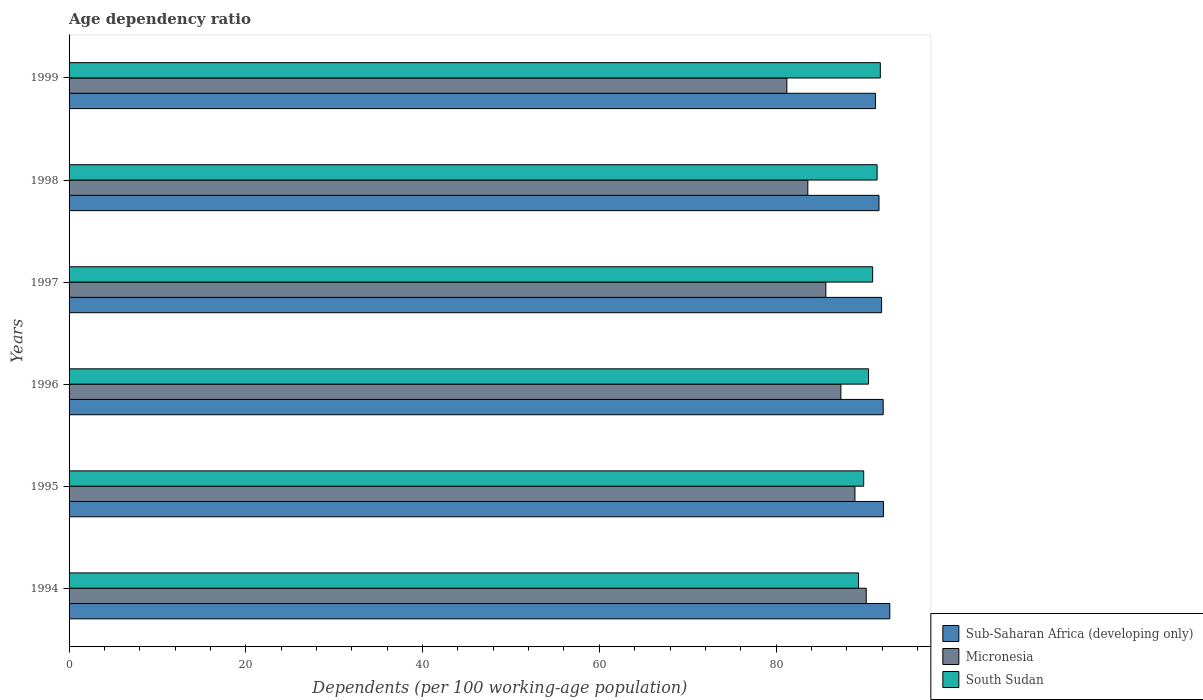How many bars are there on the 5th tick from the bottom?
Give a very brief answer. 3. What is the label of the 1st group of bars from the top?
Your answer should be very brief. 1999. What is the age dependency ratio in in Sub-Saharan Africa (developing only) in 1997?
Make the answer very short. 91.94. Across all years, what is the maximum age dependency ratio in in Micronesia?
Make the answer very short. 90.2. Across all years, what is the minimum age dependency ratio in in Sub-Saharan Africa (developing only)?
Provide a short and direct response. 91.25. In which year was the age dependency ratio in in Micronesia maximum?
Offer a terse response. 1994. What is the total age dependency ratio in in Micronesia in the graph?
Make the answer very short. 516.88. What is the difference between the age dependency ratio in in South Sudan in 1995 and that in 1996?
Ensure brevity in your answer.  -0.55. What is the difference between the age dependency ratio in in South Sudan in 1994 and the age dependency ratio in in Micronesia in 1996?
Make the answer very short. 2. What is the average age dependency ratio in in Micronesia per year?
Offer a terse response. 86.15. In the year 1995, what is the difference between the age dependency ratio in in South Sudan and age dependency ratio in in Micronesia?
Provide a short and direct response. 0.99. In how many years, is the age dependency ratio in in Sub-Saharan Africa (developing only) greater than 8 %?
Your answer should be very brief. 6. What is the ratio of the age dependency ratio in in Micronesia in 1996 to that in 1999?
Provide a succinct answer. 1.08. What is the difference between the highest and the second highest age dependency ratio in in South Sudan?
Your answer should be compact. 0.36. What is the difference between the highest and the lowest age dependency ratio in in Micronesia?
Ensure brevity in your answer.  8.98. Is the sum of the age dependency ratio in in South Sudan in 1996 and 1997 greater than the maximum age dependency ratio in in Micronesia across all years?
Provide a short and direct response. Yes. What does the 3rd bar from the top in 1995 represents?
Make the answer very short. Sub-Saharan Africa (developing only). What does the 3rd bar from the bottom in 1994 represents?
Ensure brevity in your answer.  South Sudan. How many bars are there?
Make the answer very short. 18. Are all the bars in the graph horizontal?
Provide a succinct answer. Yes. Are the values on the major ticks of X-axis written in scientific E-notation?
Your response must be concise. No. Does the graph contain any zero values?
Offer a terse response. No. Does the graph contain grids?
Your answer should be compact. No. How many legend labels are there?
Give a very brief answer. 3. How are the legend labels stacked?
Ensure brevity in your answer.  Vertical. What is the title of the graph?
Offer a very short reply. Age dependency ratio. What is the label or title of the X-axis?
Keep it short and to the point. Dependents (per 100 working-age population). What is the Dependents (per 100 working-age population) in Sub-Saharan Africa (developing only) in 1994?
Your answer should be compact. 92.87. What is the Dependents (per 100 working-age population) of Micronesia in 1994?
Keep it short and to the point. 90.2. What is the Dependents (per 100 working-age population) in South Sudan in 1994?
Your answer should be compact. 89.33. What is the Dependents (per 100 working-age population) of Sub-Saharan Africa (developing only) in 1995?
Make the answer very short. 92.15. What is the Dependents (per 100 working-age population) of Micronesia in 1995?
Give a very brief answer. 88.92. What is the Dependents (per 100 working-age population) in South Sudan in 1995?
Your answer should be compact. 89.91. What is the Dependents (per 100 working-age population) in Sub-Saharan Africa (developing only) in 1996?
Keep it short and to the point. 92.11. What is the Dependents (per 100 working-age population) of Micronesia in 1996?
Your answer should be very brief. 87.33. What is the Dependents (per 100 working-age population) of South Sudan in 1996?
Make the answer very short. 90.46. What is the Dependents (per 100 working-age population) in Sub-Saharan Africa (developing only) in 1997?
Keep it short and to the point. 91.94. What is the Dependents (per 100 working-age population) of Micronesia in 1997?
Provide a succinct answer. 85.63. What is the Dependents (per 100 working-age population) in South Sudan in 1997?
Ensure brevity in your answer.  90.92. What is the Dependents (per 100 working-age population) of Sub-Saharan Africa (developing only) in 1998?
Make the answer very short. 91.64. What is the Dependents (per 100 working-age population) of Micronesia in 1998?
Keep it short and to the point. 83.59. What is the Dependents (per 100 working-age population) of South Sudan in 1998?
Offer a terse response. 91.43. What is the Dependents (per 100 working-age population) in Sub-Saharan Africa (developing only) in 1999?
Your answer should be compact. 91.25. What is the Dependents (per 100 working-age population) in Micronesia in 1999?
Your response must be concise. 81.22. What is the Dependents (per 100 working-age population) of South Sudan in 1999?
Make the answer very short. 91.79. Across all years, what is the maximum Dependents (per 100 working-age population) in Sub-Saharan Africa (developing only)?
Your response must be concise. 92.87. Across all years, what is the maximum Dependents (per 100 working-age population) of Micronesia?
Offer a terse response. 90.2. Across all years, what is the maximum Dependents (per 100 working-age population) in South Sudan?
Ensure brevity in your answer.  91.79. Across all years, what is the minimum Dependents (per 100 working-age population) of Sub-Saharan Africa (developing only)?
Offer a terse response. 91.25. Across all years, what is the minimum Dependents (per 100 working-age population) of Micronesia?
Offer a very short reply. 81.22. Across all years, what is the minimum Dependents (per 100 working-age population) of South Sudan?
Offer a terse response. 89.33. What is the total Dependents (per 100 working-age population) in Sub-Saharan Africa (developing only) in the graph?
Provide a succinct answer. 551.96. What is the total Dependents (per 100 working-age population) in Micronesia in the graph?
Give a very brief answer. 516.88. What is the total Dependents (per 100 working-age population) in South Sudan in the graph?
Your answer should be very brief. 543.85. What is the difference between the Dependents (per 100 working-age population) of Sub-Saharan Africa (developing only) in 1994 and that in 1995?
Keep it short and to the point. 0.71. What is the difference between the Dependents (per 100 working-age population) of Micronesia in 1994 and that in 1995?
Offer a very short reply. 1.28. What is the difference between the Dependents (per 100 working-age population) in South Sudan in 1994 and that in 1995?
Keep it short and to the point. -0.58. What is the difference between the Dependents (per 100 working-age population) of Sub-Saharan Africa (developing only) in 1994 and that in 1996?
Ensure brevity in your answer.  0.75. What is the difference between the Dependents (per 100 working-age population) of Micronesia in 1994 and that in 1996?
Your answer should be very brief. 2.87. What is the difference between the Dependents (per 100 working-age population) of South Sudan in 1994 and that in 1996?
Your answer should be very brief. -1.13. What is the difference between the Dependents (per 100 working-age population) of Sub-Saharan Africa (developing only) in 1994 and that in 1997?
Give a very brief answer. 0.93. What is the difference between the Dependents (per 100 working-age population) of Micronesia in 1994 and that in 1997?
Give a very brief answer. 4.57. What is the difference between the Dependents (per 100 working-age population) in South Sudan in 1994 and that in 1997?
Your answer should be very brief. -1.59. What is the difference between the Dependents (per 100 working-age population) of Sub-Saharan Africa (developing only) in 1994 and that in 1998?
Keep it short and to the point. 1.22. What is the difference between the Dependents (per 100 working-age population) in Micronesia in 1994 and that in 1998?
Offer a terse response. 6.61. What is the difference between the Dependents (per 100 working-age population) of South Sudan in 1994 and that in 1998?
Offer a terse response. -2.1. What is the difference between the Dependents (per 100 working-age population) of Sub-Saharan Africa (developing only) in 1994 and that in 1999?
Keep it short and to the point. 1.62. What is the difference between the Dependents (per 100 working-age population) in Micronesia in 1994 and that in 1999?
Keep it short and to the point. 8.98. What is the difference between the Dependents (per 100 working-age population) in South Sudan in 1994 and that in 1999?
Keep it short and to the point. -2.46. What is the difference between the Dependents (per 100 working-age population) in Sub-Saharan Africa (developing only) in 1995 and that in 1996?
Offer a terse response. 0.04. What is the difference between the Dependents (per 100 working-age population) of Micronesia in 1995 and that in 1996?
Give a very brief answer. 1.59. What is the difference between the Dependents (per 100 working-age population) in South Sudan in 1995 and that in 1996?
Give a very brief answer. -0.55. What is the difference between the Dependents (per 100 working-age population) of Sub-Saharan Africa (developing only) in 1995 and that in 1997?
Offer a very short reply. 0.21. What is the difference between the Dependents (per 100 working-age population) of Micronesia in 1995 and that in 1997?
Your response must be concise. 3.29. What is the difference between the Dependents (per 100 working-age population) of South Sudan in 1995 and that in 1997?
Your response must be concise. -1.01. What is the difference between the Dependents (per 100 working-age population) in Sub-Saharan Africa (developing only) in 1995 and that in 1998?
Keep it short and to the point. 0.51. What is the difference between the Dependents (per 100 working-age population) of Micronesia in 1995 and that in 1998?
Offer a very short reply. 5.33. What is the difference between the Dependents (per 100 working-age population) in South Sudan in 1995 and that in 1998?
Ensure brevity in your answer.  -1.52. What is the difference between the Dependents (per 100 working-age population) in Sub-Saharan Africa (developing only) in 1995 and that in 1999?
Offer a terse response. 0.9. What is the difference between the Dependents (per 100 working-age population) of Micronesia in 1995 and that in 1999?
Your answer should be very brief. 7.7. What is the difference between the Dependents (per 100 working-age population) in South Sudan in 1995 and that in 1999?
Give a very brief answer. -1.88. What is the difference between the Dependents (per 100 working-age population) of Sub-Saharan Africa (developing only) in 1996 and that in 1997?
Offer a terse response. 0.18. What is the difference between the Dependents (per 100 working-age population) in Micronesia in 1996 and that in 1997?
Offer a very short reply. 1.7. What is the difference between the Dependents (per 100 working-age population) of South Sudan in 1996 and that in 1997?
Your answer should be very brief. -0.47. What is the difference between the Dependents (per 100 working-age population) in Sub-Saharan Africa (developing only) in 1996 and that in 1998?
Provide a succinct answer. 0.47. What is the difference between the Dependents (per 100 working-age population) of Micronesia in 1996 and that in 1998?
Your response must be concise. 3.74. What is the difference between the Dependents (per 100 working-age population) in South Sudan in 1996 and that in 1998?
Provide a succinct answer. -0.97. What is the difference between the Dependents (per 100 working-age population) of Sub-Saharan Africa (developing only) in 1996 and that in 1999?
Provide a succinct answer. 0.87. What is the difference between the Dependents (per 100 working-age population) in Micronesia in 1996 and that in 1999?
Provide a succinct answer. 6.11. What is the difference between the Dependents (per 100 working-age population) in South Sudan in 1996 and that in 1999?
Ensure brevity in your answer.  -1.33. What is the difference between the Dependents (per 100 working-age population) in Sub-Saharan Africa (developing only) in 1997 and that in 1998?
Provide a succinct answer. 0.29. What is the difference between the Dependents (per 100 working-age population) of Micronesia in 1997 and that in 1998?
Give a very brief answer. 2.04. What is the difference between the Dependents (per 100 working-age population) of South Sudan in 1997 and that in 1998?
Provide a succinct answer. -0.5. What is the difference between the Dependents (per 100 working-age population) in Sub-Saharan Africa (developing only) in 1997 and that in 1999?
Your response must be concise. 0.69. What is the difference between the Dependents (per 100 working-age population) of Micronesia in 1997 and that in 1999?
Make the answer very short. 4.41. What is the difference between the Dependents (per 100 working-age population) in South Sudan in 1997 and that in 1999?
Offer a terse response. -0.87. What is the difference between the Dependents (per 100 working-age population) of Sub-Saharan Africa (developing only) in 1998 and that in 1999?
Give a very brief answer. 0.4. What is the difference between the Dependents (per 100 working-age population) of Micronesia in 1998 and that in 1999?
Your answer should be very brief. 2.37. What is the difference between the Dependents (per 100 working-age population) of South Sudan in 1998 and that in 1999?
Offer a very short reply. -0.36. What is the difference between the Dependents (per 100 working-age population) of Sub-Saharan Africa (developing only) in 1994 and the Dependents (per 100 working-age population) of Micronesia in 1995?
Offer a very short reply. 3.94. What is the difference between the Dependents (per 100 working-age population) in Sub-Saharan Africa (developing only) in 1994 and the Dependents (per 100 working-age population) in South Sudan in 1995?
Give a very brief answer. 2.95. What is the difference between the Dependents (per 100 working-age population) of Micronesia in 1994 and the Dependents (per 100 working-age population) of South Sudan in 1995?
Your answer should be compact. 0.29. What is the difference between the Dependents (per 100 working-age population) of Sub-Saharan Africa (developing only) in 1994 and the Dependents (per 100 working-age population) of Micronesia in 1996?
Offer a very short reply. 5.54. What is the difference between the Dependents (per 100 working-age population) of Sub-Saharan Africa (developing only) in 1994 and the Dependents (per 100 working-age population) of South Sudan in 1996?
Your response must be concise. 2.41. What is the difference between the Dependents (per 100 working-age population) in Micronesia in 1994 and the Dependents (per 100 working-age population) in South Sudan in 1996?
Keep it short and to the point. -0.26. What is the difference between the Dependents (per 100 working-age population) in Sub-Saharan Africa (developing only) in 1994 and the Dependents (per 100 working-age population) in Micronesia in 1997?
Give a very brief answer. 7.24. What is the difference between the Dependents (per 100 working-age population) of Sub-Saharan Africa (developing only) in 1994 and the Dependents (per 100 working-age population) of South Sudan in 1997?
Give a very brief answer. 1.94. What is the difference between the Dependents (per 100 working-age population) of Micronesia in 1994 and the Dependents (per 100 working-age population) of South Sudan in 1997?
Make the answer very short. -0.73. What is the difference between the Dependents (per 100 working-age population) in Sub-Saharan Africa (developing only) in 1994 and the Dependents (per 100 working-age population) in Micronesia in 1998?
Your answer should be compact. 9.27. What is the difference between the Dependents (per 100 working-age population) in Sub-Saharan Africa (developing only) in 1994 and the Dependents (per 100 working-age population) in South Sudan in 1998?
Provide a succinct answer. 1.44. What is the difference between the Dependents (per 100 working-age population) in Micronesia in 1994 and the Dependents (per 100 working-age population) in South Sudan in 1998?
Give a very brief answer. -1.23. What is the difference between the Dependents (per 100 working-age population) in Sub-Saharan Africa (developing only) in 1994 and the Dependents (per 100 working-age population) in Micronesia in 1999?
Offer a terse response. 11.65. What is the difference between the Dependents (per 100 working-age population) in Sub-Saharan Africa (developing only) in 1994 and the Dependents (per 100 working-age population) in South Sudan in 1999?
Offer a very short reply. 1.07. What is the difference between the Dependents (per 100 working-age population) of Micronesia in 1994 and the Dependents (per 100 working-age population) of South Sudan in 1999?
Your answer should be compact. -1.59. What is the difference between the Dependents (per 100 working-age population) in Sub-Saharan Africa (developing only) in 1995 and the Dependents (per 100 working-age population) in Micronesia in 1996?
Ensure brevity in your answer.  4.82. What is the difference between the Dependents (per 100 working-age population) of Sub-Saharan Africa (developing only) in 1995 and the Dependents (per 100 working-age population) of South Sudan in 1996?
Your response must be concise. 1.69. What is the difference between the Dependents (per 100 working-age population) of Micronesia in 1995 and the Dependents (per 100 working-age population) of South Sudan in 1996?
Make the answer very short. -1.54. What is the difference between the Dependents (per 100 working-age population) in Sub-Saharan Africa (developing only) in 1995 and the Dependents (per 100 working-age population) in Micronesia in 1997?
Keep it short and to the point. 6.52. What is the difference between the Dependents (per 100 working-age population) in Sub-Saharan Africa (developing only) in 1995 and the Dependents (per 100 working-age population) in South Sudan in 1997?
Give a very brief answer. 1.23. What is the difference between the Dependents (per 100 working-age population) in Micronesia in 1995 and the Dependents (per 100 working-age population) in South Sudan in 1997?
Ensure brevity in your answer.  -2. What is the difference between the Dependents (per 100 working-age population) in Sub-Saharan Africa (developing only) in 1995 and the Dependents (per 100 working-age population) in Micronesia in 1998?
Ensure brevity in your answer.  8.56. What is the difference between the Dependents (per 100 working-age population) in Sub-Saharan Africa (developing only) in 1995 and the Dependents (per 100 working-age population) in South Sudan in 1998?
Your answer should be compact. 0.72. What is the difference between the Dependents (per 100 working-age population) in Micronesia in 1995 and the Dependents (per 100 working-age population) in South Sudan in 1998?
Offer a very short reply. -2.51. What is the difference between the Dependents (per 100 working-age population) in Sub-Saharan Africa (developing only) in 1995 and the Dependents (per 100 working-age population) in Micronesia in 1999?
Your answer should be very brief. 10.93. What is the difference between the Dependents (per 100 working-age population) of Sub-Saharan Africa (developing only) in 1995 and the Dependents (per 100 working-age population) of South Sudan in 1999?
Give a very brief answer. 0.36. What is the difference between the Dependents (per 100 working-age population) in Micronesia in 1995 and the Dependents (per 100 working-age population) in South Sudan in 1999?
Give a very brief answer. -2.87. What is the difference between the Dependents (per 100 working-age population) in Sub-Saharan Africa (developing only) in 1996 and the Dependents (per 100 working-age population) in Micronesia in 1997?
Offer a very short reply. 6.49. What is the difference between the Dependents (per 100 working-age population) of Sub-Saharan Africa (developing only) in 1996 and the Dependents (per 100 working-age population) of South Sudan in 1997?
Keep it short and to the point. 1.19. What is the difference between the Dependents (per 100 working-age population) in Micronesia in 1996 and the Dependents (per 100 working-age population) in South Sudan in 1997?
Offer a terse response. -3.6. What is the difference between the Dependents (per 100 working-age population) of Sub-Saharan Africa (developing only) in 1996 and the Dependents (per 100 working-age population) of Micronesia in 1998?
Provide a succinct answer. 8.52. What is the difference between the Dependents (per 100 working-age population) in Sub-Saharan Africa (developing only) in 1996 and the Dependents (per 100 working-age population) in South Sudan in 1998?
Make the answer very short. 0.69. What is the difference between the Dependents (per 100 working-age population) of Micronesia in 1996 and the Dependents (per 100 working-age population) of South Sudan in 1998?
Offer a terse response. -4.1. What is the difference between the Dependents (per 100 working-age population) in Sub-Saharan Africa (developing only) in 1996 and the Dependents (per 100 working-age population) in Micronesia in 1999?
Your response must be concise. 10.9. What is the difference between the Dependents (per 100 working-age population) of Sub-Saharan Africa (developing only) in 1996 and the Dependents (per 100 working-age population) of South Sudan in 1999?
Give a very brief answer. 0.32. What is the difference between the Dependents (per 100 working-age population) of Micronesia in 1996 and the Dependents (per 100 working-age population) of South Sudan in 1999?
Keep it short and to the point. -4.46. What is the difference between the Dependents (per 100 working-age population) in Sub-Saharan Africa (developing only) in 1997 and the Dependents (per 100 working-age population) in Micronesia in 1998?
Give a very brief answer. 8.35. What is the difference between the Dependents (per 100 working-age population) in Sub-Saharan Africa (developing only) in 1997 and the Dependents (per 100 working-age population) in South Sudan in 1998?
Provide a succinct answer. 0.51. What is the difference between the Dependents (per 100 working-age population) in Micronesia in 1997 and the Dependents (per 100 working-age population) in South Sudan in 1998?
Your answer should be compact. -5.8. What is the difference between the Dependents (per 100 working-age population) in Sub-Saharan Africa (developing only) in 1997 and the Dependents (per 100 working-age population) in Micronesia in 1999?
Provide a short and direct response. 10.72. What is the difference between the Dependents (per 100 working-age population) in Sub-Saharan Africa (developing only) in 1997 and the Dependents (per 100 working-age population) in South Sudan in 1999?
Offer a very short reply. 0.14. What is the difference between the Dependents (per 100 working-age population) in Micronesia in 1997 and the Dependents (per 100 working-age population) in South Sudan in 1999?
Make the answer very short. -6.17. What is the difference between the Dependents (per 100 working-age population) in Sub-Saharan Africa (developing only) in 1998 and the Dependents (per 100 working-age population) in Micronesia in 1999?
Your answer should be very brief. 10.43. What is the difference between the Dependents (per 100 working-age population) of Sub-Saharan Africa (developing only) in 1998 and the Dependents (per 100 working-age population) of South Sudan in 1999?
Make the answer very short. -0.15. What is the difference between the Dependents (per 100 working-age population) of Micronesia in 1998 and the Dependents (per 100 working-age population) of South Sudan in 1999?
Provide a short and direct response. -8.2. What is the average Dependents (per 100 working-age population) of Sub-Saharan Africa (developing only) per year?
Your answer should be compact. 91.99. What is the average Dependents (per 100 working-age population) of Micronesia per year?
Give a very brief answer. 86.15. What is the average Dependents (per 100 working-age population) of South Sudan per year?
Provide a short and direct response. 90.64. In the year 1994, what is the difference between the Dependents (per 100 working-age population) in Sub-Saharan Africa (developing only) and Dependents (per 100 working-age population) in Micronesia?
Offer a very short reply. 2.67. In the year 1994, what is the difference between the Dependents (per 100 working-age population) in Sub-Saharan Africa (developing only) and Dependents (per 100 working-age population) in South Sudan?
Offer a terse response. 3.53. In the year 1994, what is the difference between the Dependents (per 100 working-age population) of Micronesia and Dependents (per 100 working-age population) of South Sudan?
Offer a very short reply. 0.87. In the year 1995, what is the difference between the Dependents (per 100 working-age population) of Sub-Saharan Africa (developing only) and Dependents (per 100 working-age population) of Micronesia?
Offer a terse response. 3.23. In the year 1995, what is the difference between the Dependents (per 100 working-age population) in Sub-Saharan Africa (developing only) and Dependents (per 100 working-age population) in South Sudan?
Your answer should be compact. 2.24. In the year 1995, what is the difference between the Dependents (per 100 working-age population) in Micronesia and Dependents (per 100 working-age population) in South Sudan?
Your answer should be very brief. -0.99. In the year 1996, what is the difference between the Dependents (per 100 working-age population) of Sub-Saharan Africa (developing only) and Dependents (per 100 working-age population) of Micronesia?
Offer a terse response. 4.78. In the year 1996, what is the difference between the Dependents (per 100 working-age population) of Sub-Saharan Africa (developing only) and Dependents (per 100 working-age population) of South Sudan?
Your answer should be very brief. 1.65. In the year 1996, what is the difference between the Dependents (per 100 working-age population) of Micronesia and Dependents (per 100 working-age population) of South Sudan?
Offer a very short reply. -3.13. In the year 1997, what is the difference between the Dependents (per 100 working-age population) in Sub-Saharan Africa (developing only) and Dependents (per 100 working-age population) in Micronesia?
Offer a very short reply. 6.31. In the year 1997, what is the difference between the Dependents (per 100 working-age population) of Sub-Saharan Africa (developing only) and Dependents (per 100 working-age population) of South Sudan?
Offer a very short reply. 1.01. In the year 1997, what is the difference between the Dependents (per 100 working-age population) in Micronesia and Dependents (per 100 working-age population) in South Sudan?
Give a very brief answer. -5.3. In the year 1998, what is the difference between the Dependents (per 100 working-age population) of Sub-Saharan Africa (developing only) and Dependents (per 100 working-age population) of Micronesia?
Keep it short and to the point. 8.05. In the year 1998, what is the difference between the Dependents (per 100 working-age population) of Sub-Saharan Africa (developing only) and Dependents (per 100 working-age population) of South Sudan?
Ensure brevity in your answer.  0.21. In the year 1998, what is the difference between the Dependents (per 100 working-age population) in Micronesia and Dependents (per 100 working-age population) in South Sudan?
Offer a terse response. -7.84. In the year 1999, what is the difference between the Dependents (per 100 working-age population) in Sub-Saharan Africa (developing only) and Dependents (per 100 working-age population) in Micronesia?
Provide a succinct answer. 10.03. In the year 1999, what is the difference between the Dependents (per 100 working-age population) of Sub-Saharan Africa (developing only) and Dependents (per 100 working-age population) of South Sudan?
Make the answer very short. -0.55. In the year 1999, what is the difference between the Dependents (per 100 working-age population) in Micronesia and Dependents (per 100 working-age population) in South Sudan?
Make the answer very short. -10.58. What is the ratio of the Dependents (per 100 working-age population) in Micronesia in 1994 to that in 1995?
Your answer should be compact. 1.01. What is the ratio of the Dependents (per 100 working-age population) in South Sudan in 1994 to that in 1995?
Your response must be concise. 0.99. What is the ratio of the Dependents (per 100 working-age population) of Micronesia in 1994 to that in 1996?
Keep it short and to the point. 1.03. What is the ratio of the Dependents (per 100 working-age population) of South Sudan in 1994 to that in 1996?
Keep it short and to the point. 0.99. What is the ratio of the Dependents (per 100 working-age population) of Sub-Saharan Africa (developing only) in 1994 to that in 1997?
Offer a terse response. 1.01. What is the ratio of the Dependents (per 100 working-age population) of Micronesia in 1994 to that in 1997?
Your answer should be very brief. 1.05. What is the ratio of the Dependents (per 100 working-age population) of South Sudan in 1994 to that in 1997?
Ensure brevity in your answer.  0.98. What is the ratio of the Dependents (per 100 working-age population) in Sub-Saharan Africa (developing only) in 1994 to that in 1998?
Ensure brevity in your answer.  1.01. What is the ratio of the Dependents (per 100 working-age population) of Micronesia in 1994 to that in 1998?
Offer a terse response. 1.08. What is the ratio of the Dependents (per 100 working-age population) in South Sudan in 1994 to that in 1998?
Ensure brevity in your answer.  0.98. What is the ratio of the Dependents (per 100 working-age population) of Sub-Saharan Africa (developing only) in 1994 to that in 1999?
Keep it short and to the point. 1.02. What is the ratio of the Dependents (per 100 working-age population) of Micronesia in 1994 to that in 1999?
Your response must be concise. 1.11. What is the ratio of the Dependents (per 100 working-age population) in South Sudan in 1994 to that in 1999?
Your response must be concise. 0.97. What is the ratio of the Dependents (per 100 working-age population) of Sub-Saharan Africa (developing only) in 1995 to that in 1996?
Your answer should be very brief. 1. What is the ratio of the Dependents (per 100 working-age population) in Micronesia in 1995 to that in 1996?
Offer a very short reply. 1.02. What is the ratio of the Dependents (per 100 working-age population) of Sub-Saharan Africa (developing only) in 1995 to that in 1997?
Offer a very short reply. 1. What is the ratio of the Dependents (per 100 working-age population) in Micronesia in 1995 to that in 1997?
Give a very brief answer. 1.04. What is the ratio of the Dependents (per 100 working-age population) of Micronesia in 1995 to that in 1998?
Ensure brevity in your answer.  1.06. What is the ratio of the Dependents (per 100 working-age population) of South Sudan in 1995 to that in 1998?
Offer a terse response. 0.98. What is the ratio of the Dependents (per 100 working-age population) of Sub-Saharan Africa (developing only) in 1995 to that in 1999?
Your answer should be compact. 1.01. What is the ratio of the Dependents (per 100 working-age population) of Micronesia in 1995 to that in 1999?
Make the answer very short. 1.09. What is the ratio of the Dependents (per 100 working-age population) in South Sudan in 1995 to that in 1999?
Your response must be concise. 0.98. What is the ratio of the Dependents (per 100 working-age population) of Micronesia in 1996 to that in 1997?
Keep it short and to the point. 1.02. What is the ratio of the Dependents (per 100 working-age population) in South Sudan in 1996 to that in 1997?
Your answer should be compact. 0.99. What is the ratio of the Dependents (per 100 working-age population) in Sub-Saharan Africa (developing only) in 1996 to that in 1998?
Provide a succinct answer. 1.01. What is the ratio of the Dependents (per 100 working-age population) in Micronesia in 1996 to that in 1998?
Your answer should be compact. 1.04. What is the ratio of the Dependents (per 100 working-age population) of South Sudan in 1996 to that in 1998?
Keep it short and to the point. 0.99. What is the ratio of the Dependents (per 100 working-age population) of Sub-Saharan Africa (developing only) in 1996 to that in 1999?
Your response must be concise. 1.01. What is the ratio of the Dependents (per 100 working-age population) in Micronesia in 1996 to that in 1999?
Provide a succinct answer. 1.08. What is the ratio of the Dependents (per 100 working-age population) of South Sudan in 1996 to that in 1999?
Make the answer very short. 0.99. What is the ratio of the Dependents (per 100 working-age population) of Sub-Saharan Africa (developing only) in 1997 to that in 1998?
Keep it short and to the point. 1. What is the ratio of the Dependents (per 100 working-age population) of Micronesia in 1997 to that in 1998?
Ensure brevity in your answer.  1.02. What is the ratio of the Dependents (per 100 working-age population) of Sub-Saharan Africa (developing only) in 1997 to that in 1999?
Your response must be concise. 1.01. What is the ratio of the Dependents (per 100 working-age population) in Micronesia in 1997 to that in 1999?
Your response must be concise. 1.05. What is the ratio of the Dependents (per 100 working-age population) in Sub-Saharan Africa (developing only) in 1998 to that in 1999?
Keep it short and to the point. 1. What is the ratio of the Dependents (per 100 working-age population) in Micronesia in 1998 to that in 1999?
Make the answer very short. 1.03. What is the difference between the highest and the second highest Dependents (per 100 working-age population) in Sub-Saharan Africa (developing only)?
Provide a succinct answer. 0.71. What is the difference between the highest and the second highest Dependents (per 100 working-age population) of Micronesia?
Keep it short and to the point. 1.28. What is the difference between the highest and the second highest Dependents (per 100 working-age population) in South Sudan?
Give a very brief answer. 0.36. What is the difference between the highest and the lowest Dependents (per 100 working-age population) in Sub-Saharan Africa (developing only)?
Provide a short and direct response. 1.62. What is the difference between the highest and the lowest Dependents (per 100 working-age population) of Micronesia?
Give a very brief answer. 8.98. What is the difference between the highest and the lowest Dependents (per 100 working-age population) in South Sudan?
Make the answer very short. 2.46. 